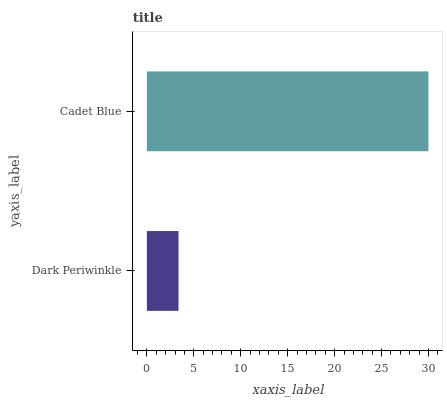Is Dark Periwinkle the minimum?
Answer yes or no. Yes. Is Cadet Blue the maximum?
Answer yes or no. Yes. Is Cadet Blue the minimum?
Answer yes or no. No. Is Cadet Blue greater than Dark Periwinkle?
Answer yes or no. Yes. Is Dark Periwinkle less than Cadet Blue?
Answer yes or no. Yes. Is Dark Periwinkle greater than Cadet Blue?
Answer yes or no. No. Is Cadet Blue less than Dark Periwinkle?
Answer yes or no. No. Is Cadet Blue the high median?
Answer yes or no. Yes. Is Dark Periwinkle the low median?
Answer yes or no. Yes. Is Dark Periwinkle the high median?
Answer yes or no. No. Is Cadet Blue the low median?
Answer yes or no. No. 